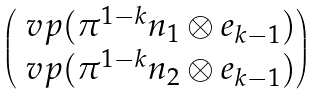<formula> <loc_0><loc_0><loc_500><loc_500>\begin{pmatrix} \ v p ( \pi ^ { 1 - k } n _ { 1 } \otimes e _ { k - 1 } ) \\ \ v p ( \pi ^ { 1 - k } n _ { 2 } \otimes e _ { k - 1 } ) \end{pmatrix}</formula> 